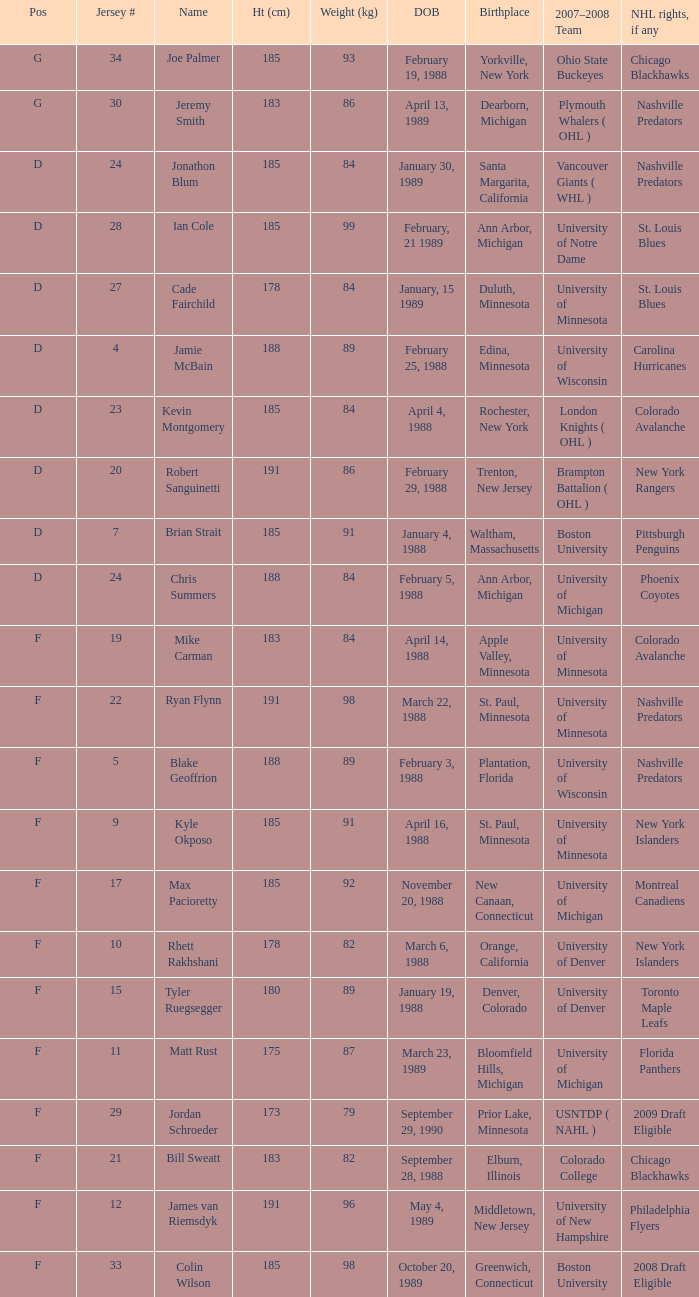Which Height (cm) has a Birthplace of bloomfield hills, michigan? 175.0. 